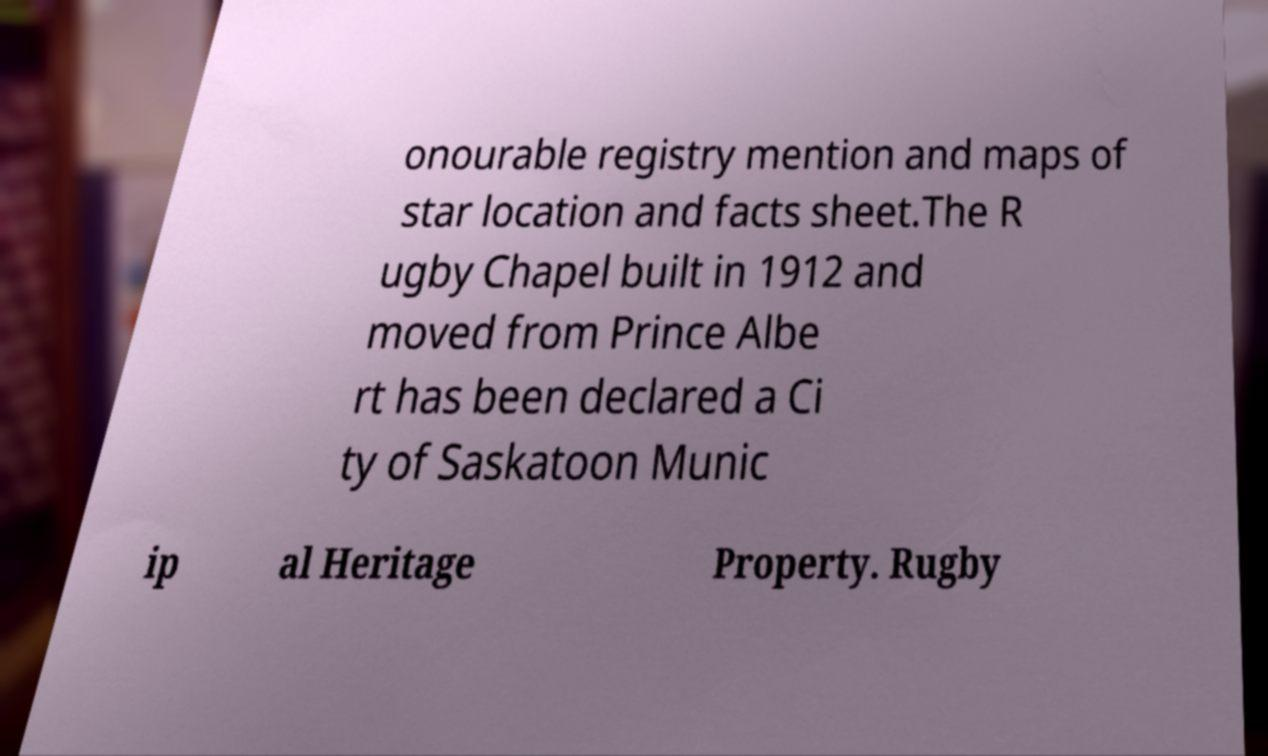There's text embedded in this image that I need extracted. Can you transcribe it verbatim? onourable registry mention and maps of star location and facts sheet.The R ugby Chapel built in 1912 and moved from Prince Albe rt has been declared a Ci ty of Saskatoon Munic ip al Heritage Property. Rugby 